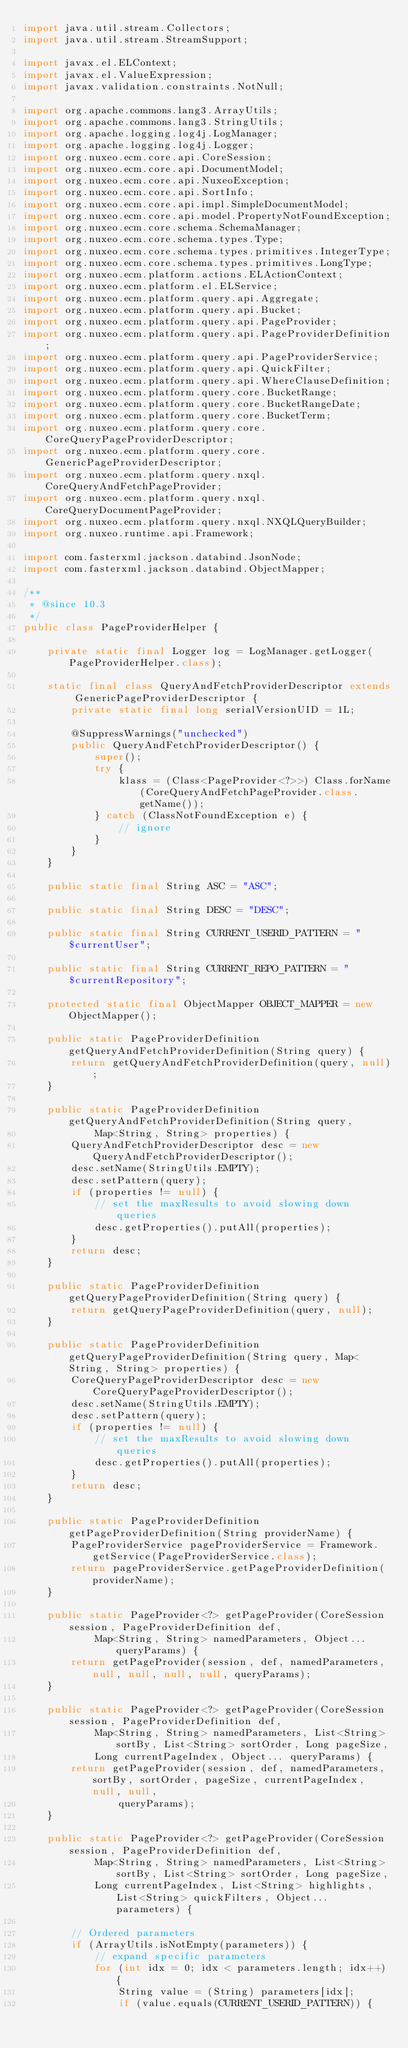Convert code to text. <code><loc_0><loc_0><loc_500><loc_500><_Java_>import java.util.stream.Collectors;
import java.util.stream.StreamSupport;

import javax.el.ELContext;
import javax.el.ValueExpression;
import javax.validation.constraints.NotNull;

import org.apache.commons.lang3.ArrayUtils;
import org.apache.commons.lang3.StringUtils;
import org.apache.logging.log4j.LogManager;
import org.apache.logging.log4j.Logger;
import org.nuxeo.ecm.core.api.CoreSession;
import org.nuxeo.ecm.core.api.DocumentModel;
import org.nuxeo.ecm.core.api.NuxeoException;
import org.nuxeo.ecm.core.api.SortInfo;
import org.nuxeo.ecm.core.api.impl.SimpleDocumentModel;
import org.nuxeo.ecm.core.api.model.PropertyNotFoundException;
import org.nuxeo.ecm.core.schema.SchemaManager;
import org.nuxeo.ecm.core.schema.types.Type;
import org.nuxeo.ecm.core.schema.types.primitives.IntegerType;
import org.nuxeo.ecm.core.schema.types.primitives.LongType;
import org.nuxeo.ecm.platform.actions.ELActionContext;
import org.nuxeo.ecm.platform.el.ELService;
import org.nuxeo.ecm.platform.query.api.Aggregate;
import org.nuxeo.ecm.platform.query.api.Bucket;
import org.nuxeo.ecm.platform.query.api.PageProvider;
import org.nuxeo.ecm.platform.query.api.PageProviderDefinition;
import org.nuxeo.ecm.platform.query.api.PageProviderService;
import org.nuxeo.ecm.platform.query.api.QuickFilter;
import org.nuxeo.ecm.platform.query.api.WhereClauseDefinition;
import org.nuxeo.ecm.platform.query.core.BucketRange;
import org.nuxeo.ecm.platform.query.core.BucketRangeDate;
import org.nuxeo.ecm.platform.query.core.BucketTerm;
import org.nuxeo.ecm.platform.query.core.CoreQueryPageProviderDescriptor;
import org.nuxeo.ecm.platform.query.core.GenericPageProviderDescriptor;
import org.nuxeo.ecm.platform.query.nxql.CoreQueryAndFetchPageProvider;
import org.nuxeo.ecm.platform.query.nxql.CoreQueryDocumentPageProvider;
import org.nuxeo.ecm.platform.query.nxql.NXQLQueryBuilder;
import org.nuxeo.runtime.api.Framework;

import com.fasterxml.jackson.databind.JsonNode;
import com.fasterxml.jackson.databind.ObjectMapper;

/**
 * @since 10.3
 */
public class PageProviderHelper {

    private static final Logger log = LogManager.getLogger(PageProviderHelper.class);

    static final class QueryAndFetchProviderDescriptor extends GenericPageProviderDescriptor {
        private static final long serialVersionUID = 1L;

        @SuppressWarnings("unchecked")
        public QueryAndFetchProviderDescriptor() {
            super();
            try {
                klass = (Class<PageProvider<?>>) Class.forName(CoreQueryAndFetchPageProvider.class.getName());
            } catch (ClassNotFoundException e) {
                // ignore
            }
        }
    }

    public static final String ASC = "ASC";

    public static final String DESC = "DESC";

    public static final String CURRENT_USERID_PATTERN = "$currentUser";

    public static final String CURRENT_REPO_PATTERN = "$currentRepository";

    protected static final ObjectMapper OBJECT_MAPPER = new ObjectMapper();

    public static PageProviderDefinition getQueryAndFetchProviderDefinition(String query) {
        return getQueryAndFetchProviderDefinition(query, null);
    }

    public static PageProviderDefinition getQueryAndFetchProviderDefinition(String query,
            Map<String, String> properties) {
        QueryAndFetchProviderDescriptor desc = new QueryAndFetchProviderDescriptor();
        desc.setName(StringUtils.EMPTY);
        desc.setPattern(query);
        if (properties != null) {
            // set the maxResults to avoid slowing down queries
            desc.getProperties().putAll(properties);
        }
        return desc;
    }

    public static PageProviderDefinition getQueryPageProviderDefinition(String query) {
        return getQueryPageProviderDefinition(query, null);
    }

    public static PageProviderDefinition getQueryPageProviderDefinition(String query, Map<String, String> properties) {
        CoreQueryPageProviderDescriptor desc = new CoreQueryPageProviderDescriptor();
        desc.setName(StringUtils.EMPTY);
        desc.setPattern(query);
        if (properties != null) {
            // set the maxResults to avoid slowing down queries
            desc.getProperties().putAll(properties);
        }
        return desc;
    }

    public static PageProviderDefinition getPageProviderDefinition(String providerName) {
        PageProviderService pageProviderService = Framework.getService(PageProviderService.class);
        return pageProviderService.getPageProviderDefinition(providerName);
    }

    public static PageProvider<?> getPageProvider(CoreSession session, PageProviderDefinition def,
            Map<String, String> namedParameters, Object... queryParams) {
        return getPageProvider(session, def, namedParameters, null, null, null, null, queryParams);
    }

    public static PageProvider<?> getPageProvider(CoreSession session, PageProviderDefinition def,
            Map<String, String> namedParameters, List<String> sortBy, List<String> sortOrder, Long pageSize,
            Long currentPageIndex, Object... queryParams) {
        return getPageProvider(session, def, namedParameters, sortBy, sortOrder, pageSize, currentPageIndex, null, null,
                queryParams);
    }

    public static PageProvider<?> getPageProvider(CoreSession session, PageProviderDefinition def,
            Map<String, String> namedParameters, List<String> sortBy, List<String> sortOrder, Long pageSize,
            Long currentPageIndex, List<String> highlights, List<String> quickFilters, Object... parameters) {

        // Ordered parameters
        if (ArrayUtils.isNotEmpty(parameters)) {
            // expand specific parameters
            for (int idx = 0; idx < parameters.length; idx++) {
                String value = (String) parameters[idx];
                if (value.equals(CURRENT_USERID_PATTERN)) {</code> 